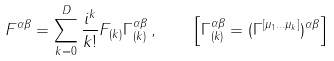<formula> <loc_0><loc_0><loc_500><loc_500>F ^ { \alpha \beta } = \sum _ { k = 0 } ^ { D } \frac { i ^ { k } } { k ! } F _ { ( k ) } \Gamma _ { ( k ) } ^ { \alpha \beta } \, , \quad \left [ \Gamma _ { ( k ) } ^ { \alpha \beta } = ( \Gamma ^ { [ \mu _ { 1 } \dots \mu _ { k } ] } ) ^ { \alpha \beta } \right ]</formula> 